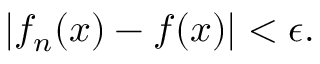Convert formula to latex. <formula><loc_0><loc_0><loc_500><loc_500>| f _ { n } ( x ) - f ( x ) | < \epsilon .</formula> 